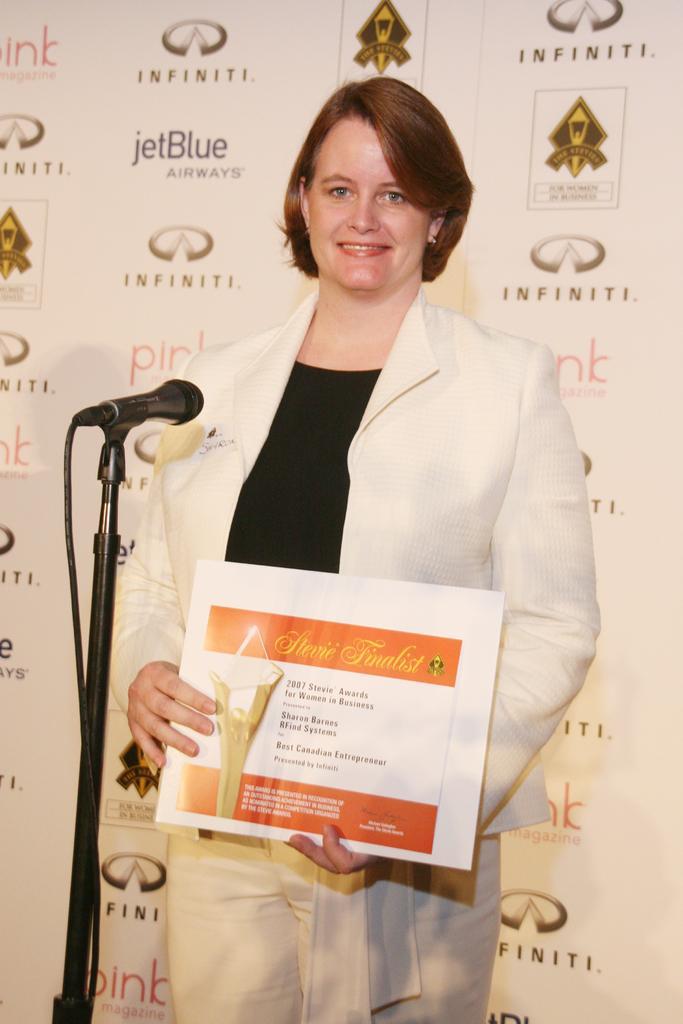In one or two sentences, can you explain what this image depicts? There is a woman holding a frame with her hands and she is smiling. Here we can see a mike. In the background there is a banner. 